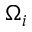Convert formula to latex. <formula><loc_0><loc_0><loc_500><loc_500>\Omega _ { i }</formula> 